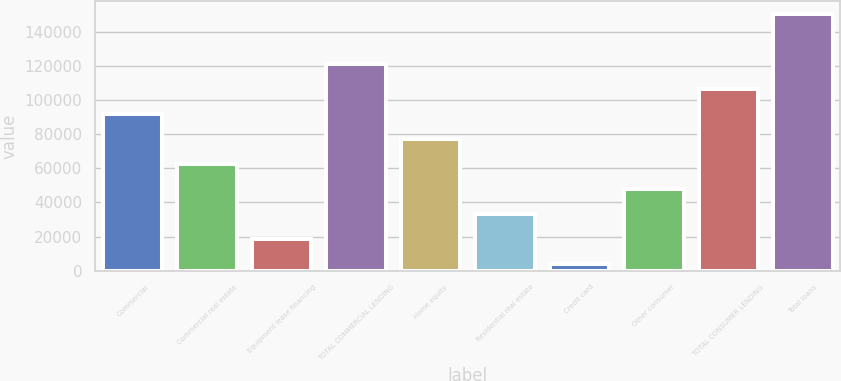<chart> <loc_0><loc_0><loc_500><loc_500><bar_chart><fcel>Commercial<fcel>Commercial real estate<fcel>Equipment lease financing<fcel>TOTAL COMMERCIAL LENDING<fcel>Home equity<fcel>Residential real estate<fcel>Credit card<fcel>Other consumer<fcel>TOTAL CONSUMER LENDING<fcel>Total loans<nl><fcel>91925<fcel>62590<fcel>18587.5<fcel>121260<fcel>77257.5<fcel>33255<fcel>3920<fcel>47922.5<fcel>106592<fcel>150595<nl></chart> 